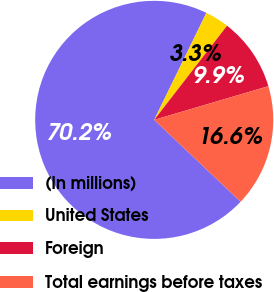Convert chart. <chart><loc_0><loc_0><loc_500><loc_500><pie_chart><fcel>(In millions)<fcel>United States<fcel>Foreign<fcel>Total earnings before taxes<nl><fcel>70.15%<fcel>3.26%<fcel>9.95%<fcel>16.64%<nl></chart> 